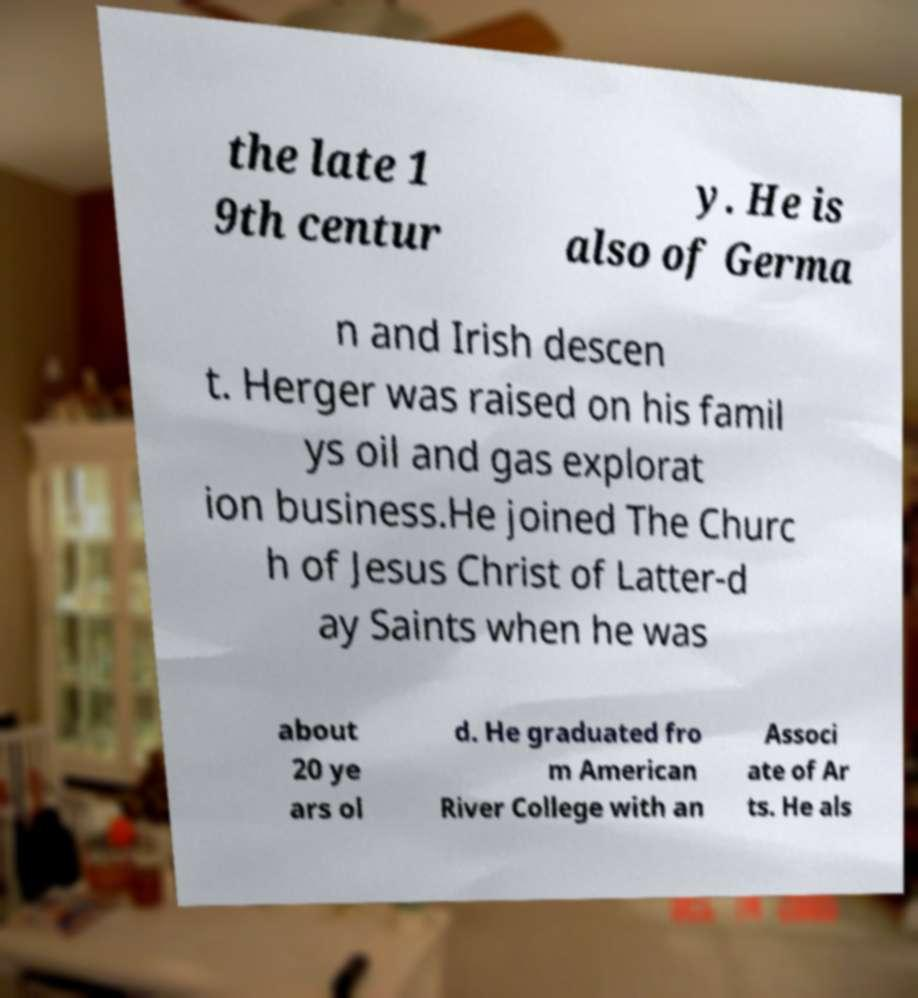For documentation purposes, I need the text within this image transcribed. Could you provide that? the late 1 9th centur y. He is also of Germa n and Irish descen t. Herger was raised on his famil ys oil and gas explorat ion business.He joined The Churc h of Jesus Christ of Latter-d ay Saints when he was about 20 ye ars ol d. He graduated fro m American River College with an Associ ate of Ar ts. He als 